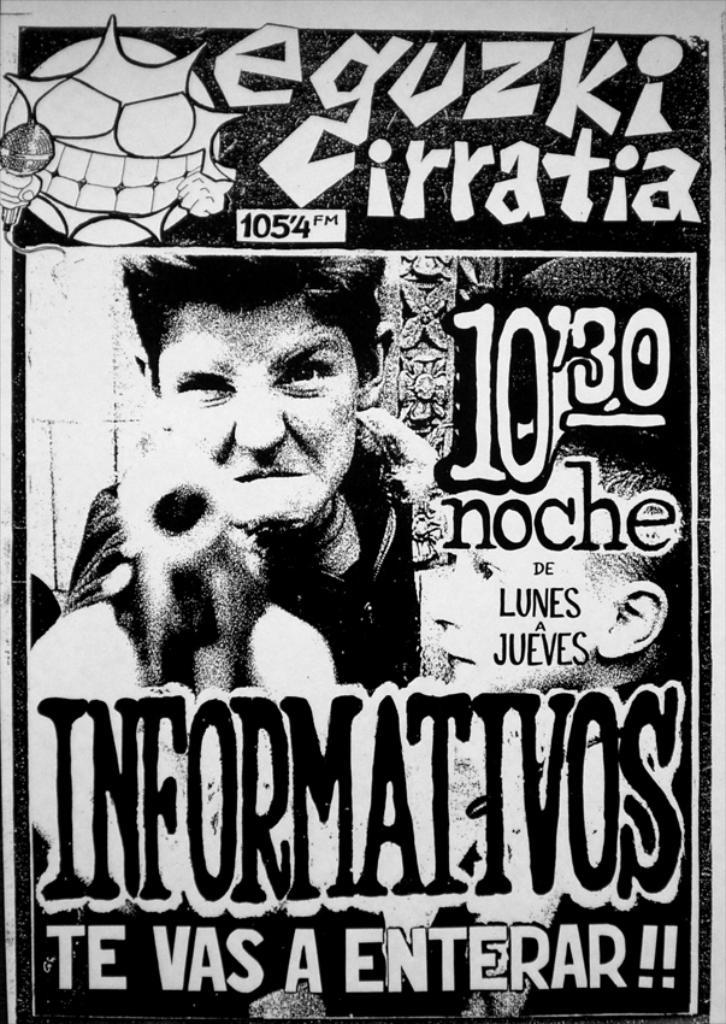<image>
Offer a succinct explanation of the picture presented. A poster with a guy pointing a guy that says Equzki Irratia on it. 